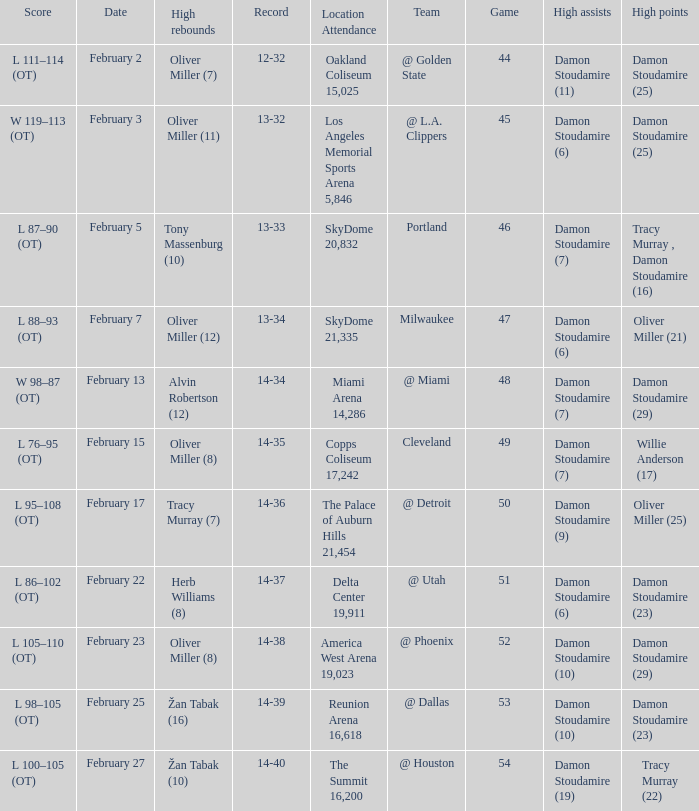How many locations have a record of 14-38? 1.0. 